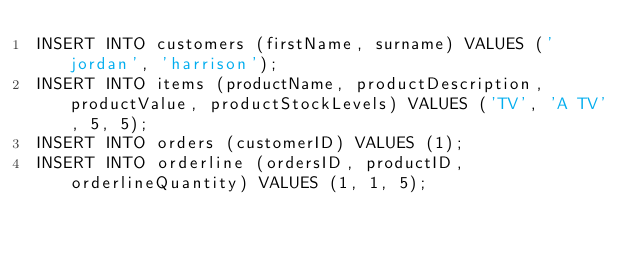Convert code to text. <code><loc_0><loc_0><loc_500><loc_500><_SQL_>INSERT INTO customers (firstName, surname) VALUES ('jordan', 'harrison');
INSERT INTO items (productName, productDescription, productValue, productStockLevels) VALUES ('TV', 'A TV', 5, 5);
INSERT INTO orders (customerID) VALUES (1);
INSERT INTO orderline (ordersID, productID, orderlineQuantity) VALUES (1, 1, 5);</code> 